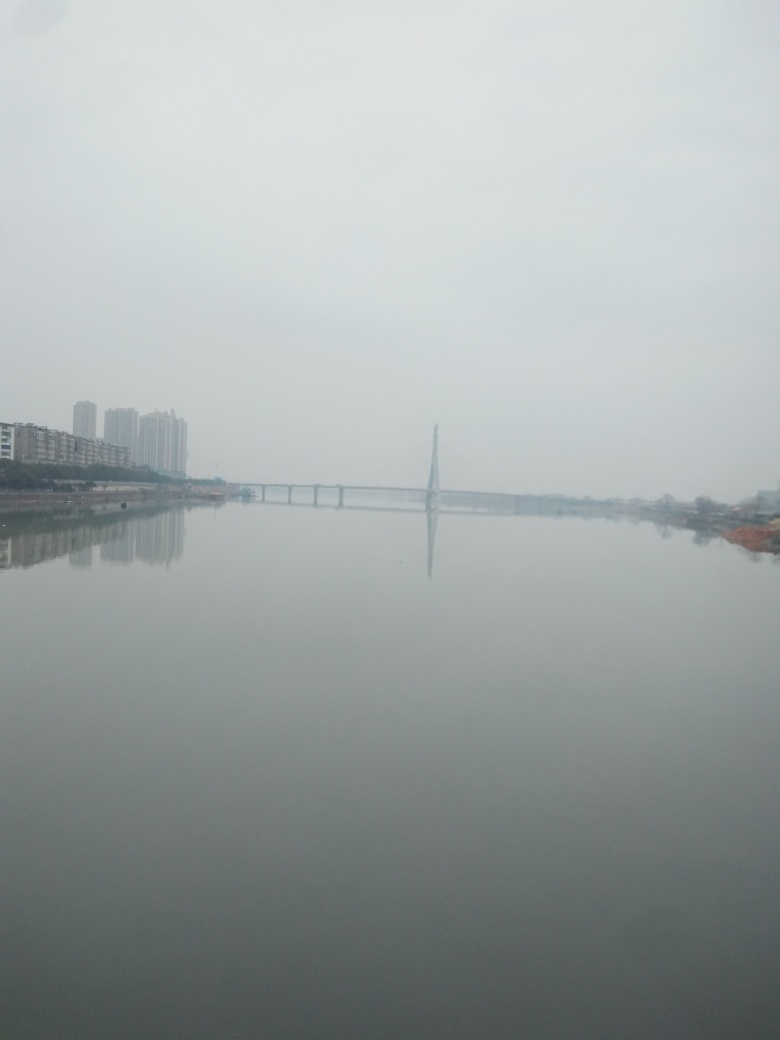What can you infer about the location depicted in this image? The image features a calm river with a bridge spanning across and buildings visible in the distance. It suggests an urban riverside location, likely on the outskirts of a city where the waterway acts as a conduit for both transportation and leisure activities. The presence of high-rise buildings indicates that it might be in a relatively developed area. How might the environment impact the mood or interpretation of this image? The tranquility of the water and the haze creates a subdued or serene mood, possibly evoking feelings of solitude or calmness. The haziness can also give a sense of mystery or stillness. However, if the viewer interprets the haze as a sign of pollution, it could also lead to thoughts on environmental concerns and urbanization's impact on natural landscapes. 